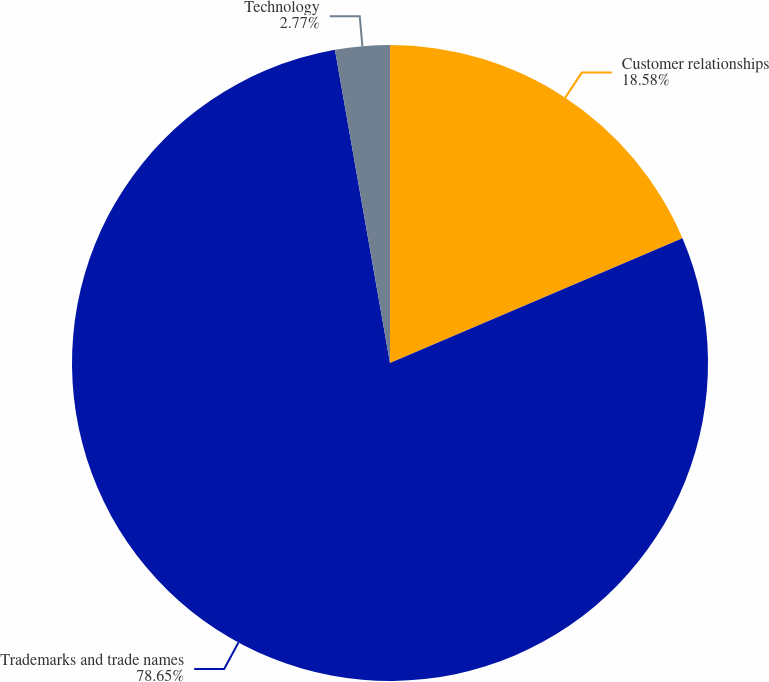Convert chart to OTSL. <chart><loc_0><loc_0><loc_500><loc_500><pie_chart><fcel>Customer relationships<fcel>Trademarks and trade names<fcel>Technology<nl><fcel>18.58%<fcel>78.65%<fcel>2.77%<nl></chart> 